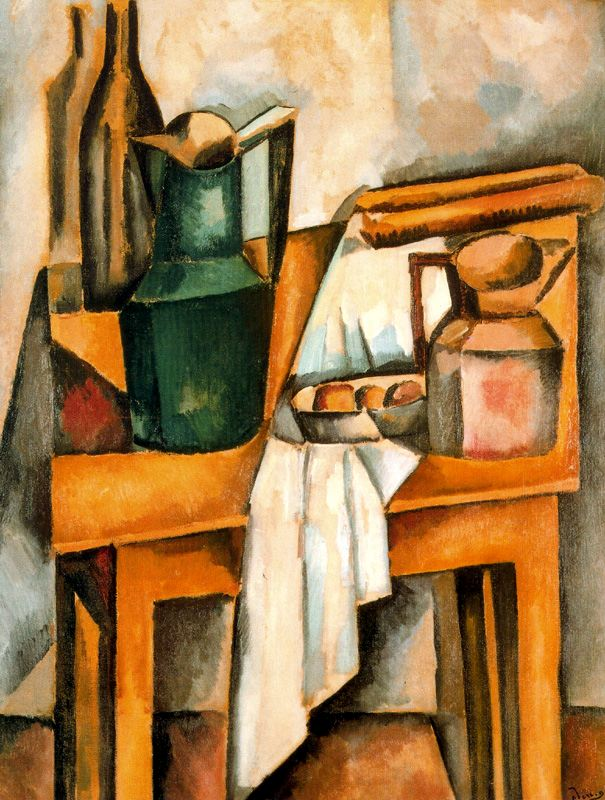What does the style of painting tell us about the era in which it was created? The Cubist style of the painting reflects the early 20th century, a period of rapid modernization and experimentation in the arts. Cubism, pioneered by artists like Picasso and Braque, broke away from traditional perspectives and embraced abstract forms and multiple viewpoints. Such innovations in art were paralleled by contemporaneous advancements in technology, science, and philosophy, suggesting a society in flux. This painting, with its abstract forms and emphasis on geometry, mirrors the era's fascination with redefining the boundaries of expression and perception. 